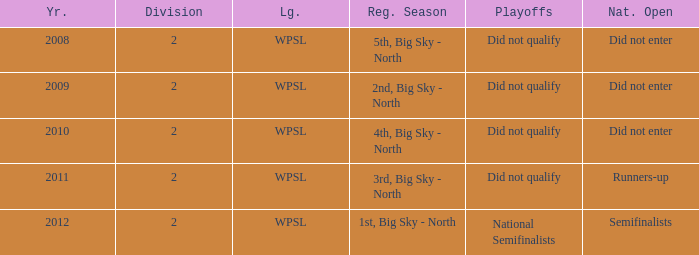What league was involved in 2008? WPSL. 